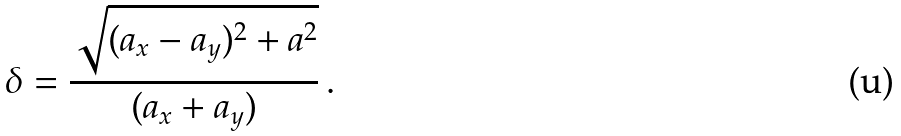<formula> <loc_0><loc_0><loc_500><loc_500>\delta = { \frac { \sqrt { ( a _ { x } - a _ { y } ) ^ { 2 } + a ^ { 2 } } } { ( a _ { x } + a _ { y } ) } } \, .</formula> 